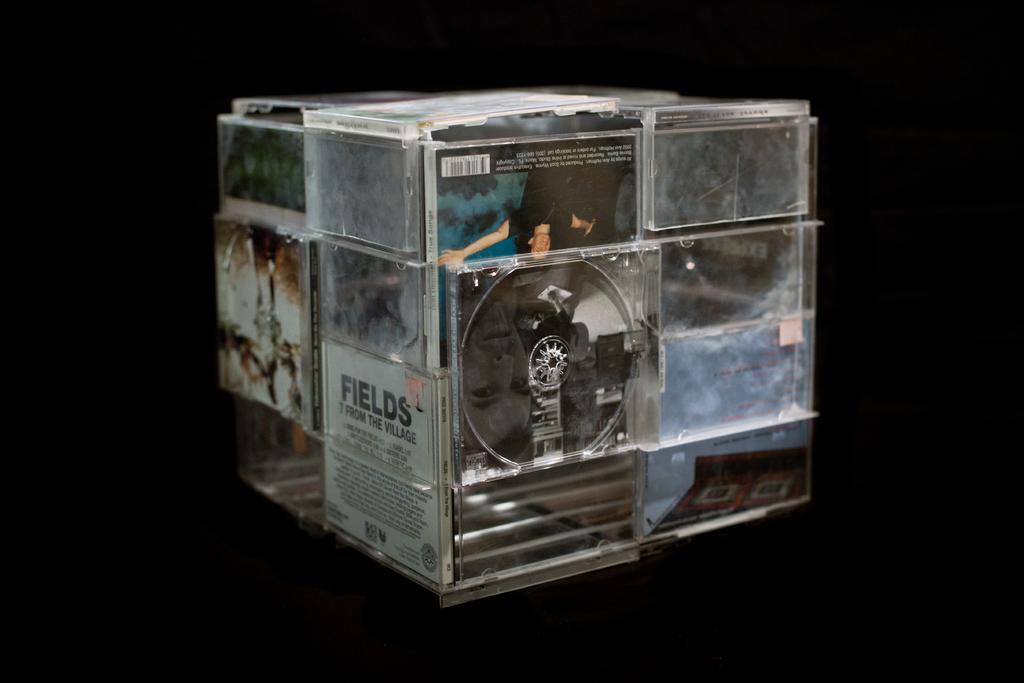What kind of music is on the fields cd?
Offer a very short reply. Unanswerable. Who's cd is this?
Offer a very short reply. Fields. 